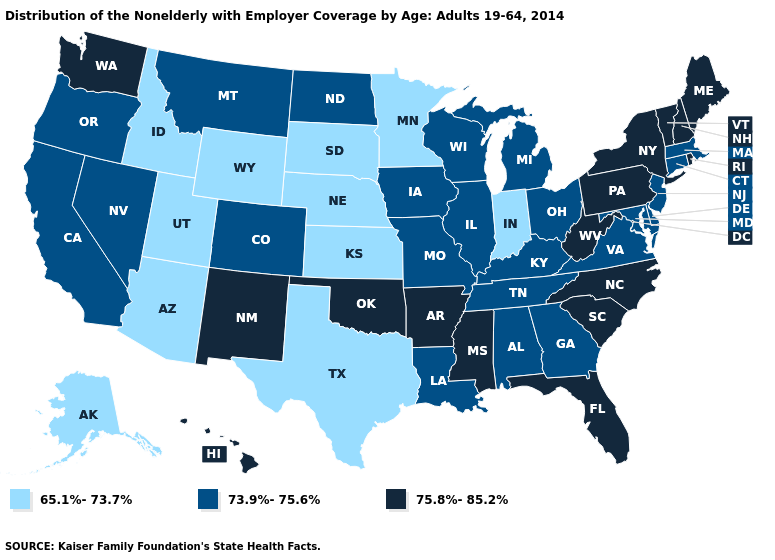Among the states that border Maine , which have the lowest value?
Answer briefly. New Hampshire. Among the states that border Arkansas , does Oklahoma have the lowest value?
Give a very brief answer. No. Does Georgia have a higher value than Minnesota?
Quick response, please. Yes. What is the lowest value in states that border Michigan?
Keep it brief. 65.1%-73.7%. What is the lowest value in the South?
Concise answer only. 65.1%-73.7%. Does Missouri have the lowest value in the USA?
Write a very short answer. No. Name the states that have a value in the range 75.8%-85.2%?
Concise answer only. Arkansas, Florida, Hawaii, Maine, Mississippi, New Hampshire, New Mexico, New York, North Carolina, Oklahoma, Pennsylvania, Rhode Island, South Carolina, Vermont, Washington, West Virginia. What is the highest value in the USA?
Write a very short answer. 75.8%-85.2%. Name the states that have a value in the range 65.1%-73.7%?
Answer briefly. Alaska, Arizona, Idaho, Indiana, Kansas, Minnesota, Nebraska, South Dakota, Texas, Utah, Wyoming. Name the states that have a value in the range 73.9%-75.6%?
Answer briefly. Alabama, California, Colorado, Connecticut, Delaware, Georgia, Illinois, Iowa, Kentucky, Louisiana, Maryland, Massachusetts, Michigan, Missouri, Montana, Nevada, New Jersey, North Dakota, Ohio, Oregon, Tennessee, Virginia, Wisconsin. What is the lowest value in the USA?
Give a very brief answer. 65.1%-73.7%. Name the states that have a value in the range 75.8%-85.2%?
Answer briefly. Arkansas, Florida, Hawaii, Maine, Mississippi, New Hampshire, New Mexico, New York, North Carolina, Oklahoma, Pennsylvania, Rhode Island, South Carolina, Vermont, Washington, West Virginia. Does Delaware have the lowest value in the USA?
Be succinct. No. Name the states that have a value in the range 75.8%-85.2%?
Keep it brief. Arkansas, Florida, Hawaii, Maine, Mississippi, New Hampshire, New Mexico, New York, North Carolina, Oklahoma, Pennsylvania, Rhode Island, South Carolina, Vermont, Washington, West Virginia. Does Mississippi have the same value as Pennsylvania?
Give a very brief answer. Yes. 